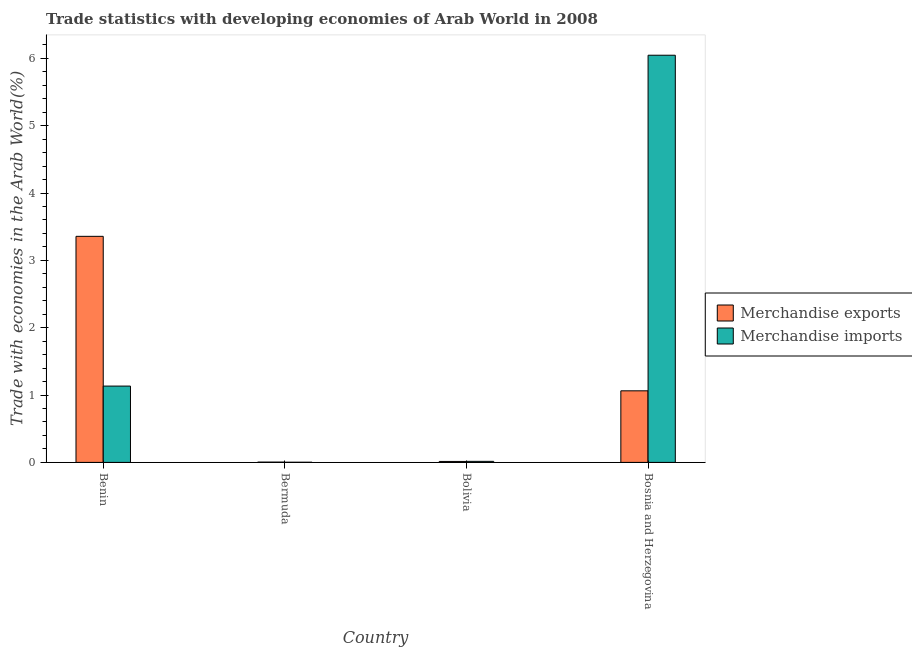How many different coloured bars are there?
Give a very brief answer. 2. How many groups of bars are there?
Offer a terse response. 4. Are the number of bars per tick equal to the number of legend labels?
Offer a terse response. Yes. How many bars are there on the 1st tick from the left?
Offer a very short reply. 2. What is the label of the 4th group of bars from the left?
Provide a succinct answer. Bosnia and Herzegovina. In how many cases, is the number of bars for a given country not equal to the number of legend labels?
Give a very brief answer. 0. What is the merchandise imports in Bolivia?
Provide a succinct answer. 0.02. Across all countries, what is the maximum merchandise imports?
Your answer should be very brief. 6.05. Across all countries, what is the minimum merchandise exports?
Your response must be concise. 0. In which country was the merchandise exports maximum?
Your answer should be compact. Benin. In which country was the merchandise imports minimum?
Provide a succinct answer. Bermuda. What is the total merchandise imports in the graph?
Make the answer very short. 7.2. What is the difference between the merchandise imports in Bermuda and that in Bosnia and Herzegovina?
Provide a succinct answer. -6.04. What is the difference between the merchandise imports in Bolivia and the merchandise exports in Benin?
Offer a very short reply. -3.34. What is the average merchandise exports per country?
Offer a terse response. 1.11. What is the difference between the merchandise exports and merchandise imports in Bosnia and Herzegovina?
Your answer should be compact. -4.98. What is the ratio of the merchandise imports in Bermuda to that in Bosnia and Herzegovina?
Your answer should be compact. 0. Is the difference between the merchandise exports in Bermuda and Bosnia and Herzegovina greater than the difference between the merchandise imports in Bermuda and Bosnia and Herzegovina?
Provide a succinct answer. Yes. What is the difference between the highest and the second highest merchandise exports?
Keep it short and to the point. 2.29. What is the difference between the highest and the lowest merchandise exports?
Give a very brief answer. 3.35. What does the 2nd bar from the right in Bermuda represents?
Your response must be concise. Merchandise exports. Are all the bars in the graph horizontal?
Your answer should be very brief. No. Are the values on the major ticks of Y-axis written in scientific E-notation?
Make the answer very short. No. How many legend labels are there?
Your answer should be very brief. 2. What is the title of the graph?
Give a very brief answer. Trade statistics with developing economies of Arab World in 2008. Does "Age 65(male)" appear as one of the legend labels in the graph?
Make the answer very short. No. What is the label or title of the X-axis?
Give a very brief answer. Country. What is the label or title of the Y-axis?
Your response must be concise. Trade with economies in the Arab World(%). What is the Trade with economies in the Arab World(%) of Merchandise exports in Benin?
Provide a succinct answer. 3.36. What is the Trade with economies in the Arab World(%) of Merchandise imports in Benin?
Offer a very short reply. 1.13. What is the Trade with economies in the Arab World(%) of Merchandise exports in Bermuda?
Keep it short and to the point. 0. What is the Trade with economies in the Arab World(%) of Merchandise imports in Bermuda?
Your response must be concise. 0. What is the Trade with economies in the Arab World(%) in Merchandise exports in Bolivia?
Make the answer very short. 0.01. What is the Trade with economies in the Arab World(%) in Merchandise imports in Bolivia?
Keep it short and to the point. 0.02. What is the Trade with economies in the Arab World(%) of Merchandise exports in Bosnia and Herzegovina?
Make the answer very short. 1.06. What is the Trade with economies in the Arab World(%) in Merchandise imports in Bosnia and Herzegovina?
Your answer should be compact. 6.05. Across all countries, what is the maximum Trade with economies in the Arab World(%) of Merchandise exports?
Provide a succinct answer. 3.36. Across all countries, what is the maximum Trade with economies in the Arab World(%) of Merchandise imports?
Keep it short and to the point. 6.05. Across all countries, what is the minimum Trade with economies in the Arab World(%) of Merchandise exports?
Keep it short and to the point. 0. Across all countries, what is the minimum Trade with economies in the Arab World(%) of Merchandise imports?
Offer a very short reply. 0. What is the total Trade with economies in the Arab World(%) of Merchandise exports in the graph?
Your answer should be compact. 4.44. What is the total Trade with economies in the Arab World(%) of Merchandise imports in the graph?
Provide a succinct answer. 7.2. What is the difference between the Trade with economies in the Arab World(%) in Merchandise exports in Benin and that in Bermuda?
Your answer should be compact. 3.35. What is the difference between the Trade with economies in the Arab World(%) of Merchandise imports in Benin and that in Bermuda?
Offer a very short reply. 1.13. What is the difference between the Trade with economies in the Arab World(%) in Merchandise exports in Benin and that in Bolivia?
Offer a terse response. 3.34. What is the difference between the Trade with economies in the Arab World(%) in Merchandise imports in Benin and that in Bolivia?
Provide a succinct answer. 1.12. What is the difference between the Trade with economies in the Arab World(%) in Merchandise exports in Benin and that in Bosnia and Herzegovina?
Provide a succinct answer. 2.29. What is the difference between the Trade with economies in the Arab World(%) of Merchandise imports in Benin and that in Bosnia and Herzegovina?
Keep it short and to the point. -4.91. What is the difference between the Trade with economies in the Arab World(%) in Merchandise exports in Bermuda and that in Bolivia?
Your answer should be compact. -0.01. What is the difference between the Trade with economies in the Arab World(%) of Merchandise imports in Bermuda and that in Bolivia?
Your response must be concise. -0.01. What is the difference between the Trade with economies in the Arab World(%) in Merchandise exports in Bermuda and that in Bosnia and Herzegovina?
Provide a succinct answer. -1.06. What is the difference between the Trade with economies in the Arab World(%) in Merchandise imports in Bermuda and that in Bosnia and Herzegovina?
Offer a very short reply. -6.04. What is the difference between the Trade with economies in the Arab World(%) in Merchandise exports in Bolivia and that in Bosnia and Herzegovina?
Provide a short and direct response. -1.05. What is the difference between the Trade with economies in the Arab World(%) in Merchandise imports in Bolivia and that in Bosnia and Herzegovina?
Make the answer very short. -6.03. What is the difference between the Trade with economies in the Arab World(%) in Merchandise exports in Benin and the Trade with economies in the Arab World(%) in Merchandise imports in Bermuda?
Provide a short and direct response. 3.36. What is the difference between the Trade with economies in the Arab World(%) of Merchandise exports in Benin and the Trade with economies in the Arab World(%) of Merchandise imports in Bolivia?
Offer a terse response. 3.34. What is the difference between the Trade with economies in the Arab World(%) of Merchandise exports in Benin and the Trade with economies in the Arab World(%) of Merchandise imports in Bosnia and Herzegovina?
Your answer should be very brief. -2.69. What is the difference between the Trade with economies in the Arab World(%) of Merchandise exports in Bermuda and the Trade with economies in the Arab World(%) of Merchandise imports in Bolivia?
Provide a short and direct response. -0.01. What is the difference between the Trade with economies in the Arab World(%) of Merchandise exports in Bermuda and the Trade with economies in the Arab World(%) of Merchandise imports in Bosnia and Herzegovina?
Your answer should be very brief. -6.04. What is the difference between the Trade with economies in the Arab World(%) of Merchandise exports in Bolivia and the Trade with economies in the Arab World(%) of Merchandise imports in Bosnia and Herzegovina?
Ensure brevity in your answer.  -6.03. What is the average Trade with economies in the Arab World(%) in Merchandise exports per country?
Offer a very short reply. 1.11. What is the average Trade with economies in the Arab World(%) in Merchandise imports per country?
Offer a terse response. 1.8. What is the difference between the Trade with economies in the Arab World(%) in Merchandise exports and Trade with economies in the Arab World(%) in Merchandise imports in Benin?
Offer a very short reply. 2.22. What is the difference between the Trade with economies in the Arab World(%) in Merchandise exports and Trade with economies in the Arab World(%) in Merchandise imports in Bermuda?
Provide a succinct answer. 0. What is the difference between the Trade with economies in the Arab World(%) in Merchandise exports and Trade with economies in the Arab World(%) in Merchandise imports in Bolivia?
Provide a short and direct response. -0. What is the difference between the Trade with economies in the Arab World(%) of Merchandise exports and Trade with economies in the Arab World(%) of Merchandise imports in Bosnia and Herzegovina?
Provide a succinct answer. -4.98. What is the ratio of the Trade with economies in the Arab World(%) in Merchandise exports in Benin to that in Bermuda?
Your response must be concise. 776.35. What is the ratio of the Trade with economies in the Arab World(%) of Merchandise imports in Benin to that in Bermuda?
Offer a terse response. 496.47. What is the ratio of the Trade with economies in the Arab World(%) in Merchandise exports in Benin to that in Bolivia?
Offer a very short reply. 236.33. What is the ratio of the Trade with economies in the Arab World(%) of Merchandise imports in Benin to that in Bolivia?
Offer a very short reply. 73.16. What is the ratio of the Trade with economies in the Arab World(%) of Merchandise exports in Benin to that in Bosnia and Herzegovina?
Keep it short and to the point. 3.16. What is the ratio of the Trade with economies in the Arab World(%) of Merchandise imports in Benin to that in Bosnia and Herzegovina?
Make the answer very short. 0.19. What is the ratio of the Trade with economies in the Arab World(%) of Merchandise exports in Bermuda to that in Bolivia?
Give a very brief answer. 0.3. What is the ratio of the Trade with economies in the Arab World(%) in Merchandise imports in Bermuda to that in Bolivia?
Your response must be concise. 0.15. What is the ratio of the Trade with economies in the Arab World(%) of Merchandise exports in Bermuda to that in Bosnia and Herzegovina?
Your answer should be compact. 0. What is the ratio of the Trade with economies in the Arab World(%) in Merchandise exports in Bolivia to that in Bosnia and Herzegovina?
Provide a succinct answer. 0.01. What is the ratio of the Trade with economies in the Arab World(%) of Merchandise imports in Bolivia to that in Bosnia and Herzegovina?
Ensure brevity in your answer.  0. What is the difference between the highest and the second highest Trade with economies in the Arab World(%) of Merchandise exports?
Provide a short and direct response. 2.29. What is the difference between the highest and the second highest Trade with economies in the Arab World(%) in Merchandise imports?
Offer a very short reply. 4.91. What is the difference between the highest and the lowest Trade with economies in the Arab World(%) of Merchandise exports?
Keep it short and to the point. 3.35. What is the difference between the highest and the lowest Trade with economies in the Arab World(%) of Merchandise imports?
Give a very brief answer. 6.04. 